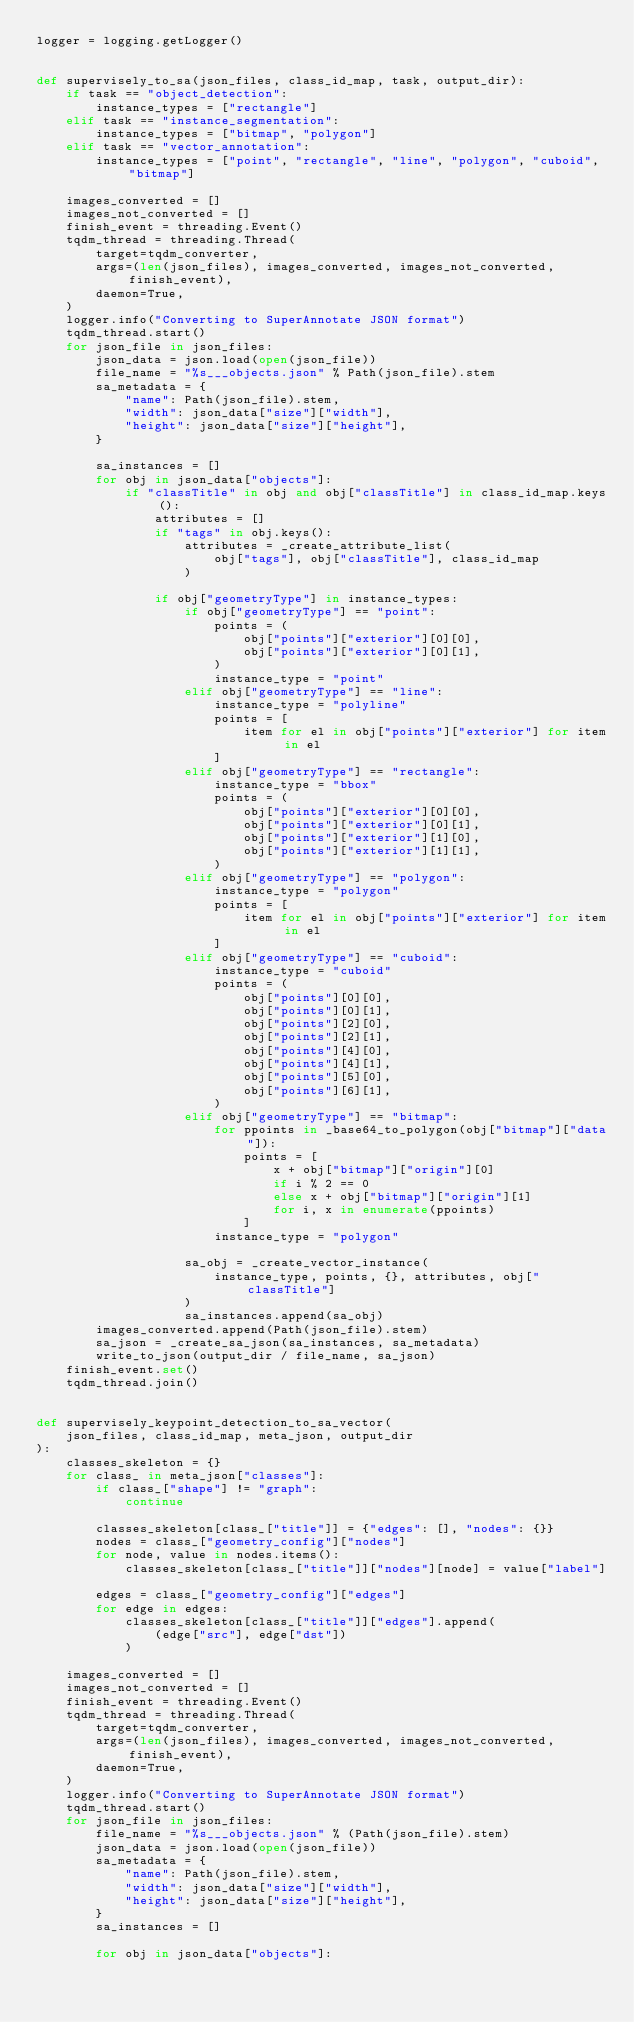<code> <loc_0><loc_0><loc_500><loc_500><_Python_>logger = logging.getLogger()


def supervisely_to_sa(json_files, class_id_map, task, output_dir):
    if task == "object_detection":
        instance_types = ["rectangle"]
    elif task == "instance_segmentation":
        instance_types = ["bitmap", "polygon"]
    elif task == "vector_annotation":
        instance_types = ["point", "rectangle", "line", "polygon", "cuboid", "bitmap"]

    images_converted = []
    images_not_converted = []
    finish_event = threading.Event()
    tqdm_thread = threading.Thread(
        target=tqdm_converter,
        args=(len(json_files), images_converted, images_not_converted, finish_event),
        daemon=True,
    )
    logger.info("Converting to SuperAnnotate JSON format")
    tqdm_thread.start()
    for json_file in json_files:
        json_data = json.load(open(json_file))
        file_name = "%s___objects.json" % Path(json_file).stem
        sa_metadata = {
            "name": Path(json_file).stem,
            "width": json_data["size"]["width"],
            "height": json_data["size"]["height"],
        }

        sa_instances = []
        for obj in json_data["objects"]:
            if "classTitle" in obj and obj["classTitle"] in class_id_map.keys():
                attributes = []
                if "tags" in obj.keys():
                    attributes = _create_attribute_list(
                        obj["tags"], obj["classTitle"], class_id_map
                    )

                if obj["geometryType"] in instance_types:
                    if obj["geometryType"] == "point":
                        points = (
                            obj["points"]["exterior"][0][0],
                            obj["points"]["exterior"][0][1],
                        )
                        instance_type = "point"
                    elif obj["geometryType"] == "line":
                        instance_type = "polyline"
                        points = [
                            item for el in obj["points"]["exterior"] for item in el
                        ]
                    elif obj["geometryType"] == "rectangle":
                        instance_type = "bbox"
                        points = (
                            obj["points"]["exterior"][0][0],
                            obj["points"]["exterior"][0][1],
                            obj["points"]["exterior"][1][0],
                            obj["points"]["exterior"][1][1],
                        )
                    elif obj["geometryType"] == "polygon":
                        instance_type = "polygon"
                        points = [
                            item for el in obj["points"]["exterior"] for item in el
                        ]
                    elif obj["geometryType"] == "cuboid":
                        instance_type = "cuboid"
                        points = (
                            obj["points"][0][0],
                            obj["points"][0][1],
                            obj["points"][2][0],
                            obj["points"][2][1],
                            obj["points"][4][0],
                            obj["points"][4][1],
                            obj["points"][5][0],
                            obj["points"][6][1],
                        )
                    elif obj["geometryType"] == "bitmap":
                        for ppoints in _base64_to_polygon(obj["bitmap"]["data"]):
                            points = [
                                x + obj["bitmap"]["origin"][0]
                                if i % 2 == 0
                                else x + obj["bitmap"]["origin"][1]
                                for i, x in enumerate(ppoints)
                            ]
                        instance_type = "polygon"

                    sa_obj = _create_vector_instance(
                        instance_type, points, {}, attributes, obj["classTitle"]
                    )
                    sa_instances.append(sa_obj)
        images_converted.append(Path(json_file).stem)
        sa_json = _create_sa_json(sa_instances, sa_metadata)
        write_to_json(output_dir / file_name, sa_json)
    finish_event.set()
    tqdm_thread.join()


def supervisely_keypoint_detection_to_sa_vector(
    json_files, class_id_map, meta_json, output_dir
):
    classes_skeleton = {}
    for class_ in meta_json["classes"]:
        if class_["shape"] != "graph":
            continue

        classes_skeleton[class_["title"]] = {"edges": [], "nodes": {}}
        nodes = class_["geometry_config"]["nodes"]
        for node, value in nodes.items():
            classes_skeleton[class_["title"]]["nodes"][node] = value["label"]

        edges = class_["geometry_config"]["edges"]
        for edge in edges:
            classes_skeleton[class_["title"]]["edges"].append(
                (edge["src"], edge["dst"])
            )

    images_converted = []
    images_not_converted = []
    finish_event = threading.Event()
    tqdm_thread = threading.Thread(
        target=tqdm_converter,
        args=(len(json_files), images_converted, images_not_converted, finish_event),
        daemon=True,
    )
    logger.info("Converting to SuperAnnotate JSON format")
    tqdm_thread.start()
    for json_file in json_files:
        file_name = "%s___objects.json" % (Path(json_file).stem)
        json_data = json.load(open(json_file))
        sa_metadata = {
            "name": Path(json_file).stem,
            "width": json_data["size"]["width"],
            "height": json_data["size"]["height"],
        }
        sa_instances = []

        for obj in json_data["objects"]:</code> 